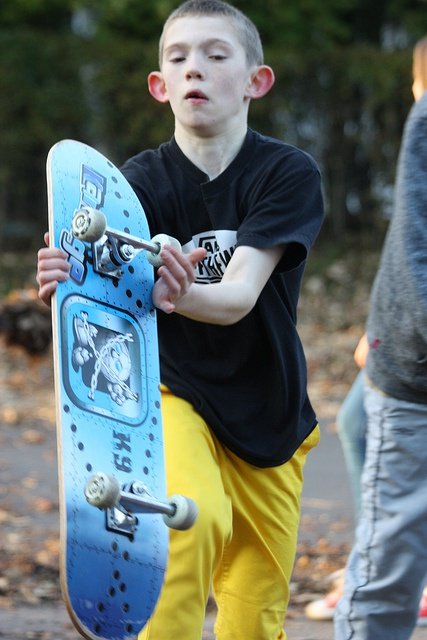Describe the objects in this image and their specific colors. I can see people in black, darkgray, olive, and khaki tones, skateboard in black, lightblue, and blue tones, and people in black, gray, and darkgray tones in this image. 